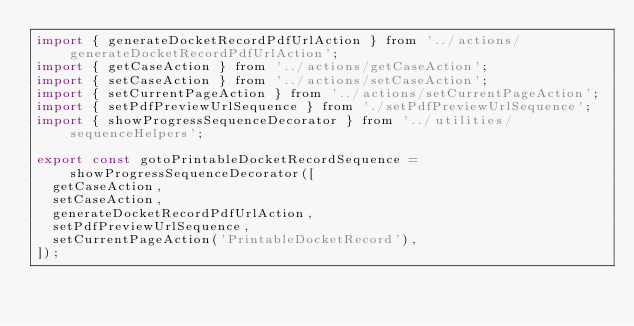Convert code to text. <code><loc_0><loc_0><loc_500><loc_500><_JavaScript_>import { generateDocketRecordPdfUrlAction } from '../actions/generateDocketRecordPdfUrlAction';
import { getCaseAction } from '../actions/getCaseAction';
import { setCaseAction } from '../actions/setCaseAction';
import { setCurrentPageAction } from '../actions/setCurrentPageAction';
import { setPdfPreviewUrlSequence } from './setPdfPreviewUrlSequence';
import { showProgressSequenceDecorator } from '../utilities/sequenceHelpers';

export const gotoPrintableDocketRecordSequence = showProgressSequenceDecorator([
  getCaseAction,
  setCaseAction,
  generateDocketRecordPdfUrlAction,
  setPdfPreviewUrlSequence,
  setCurrentPageAction('PrintableDocketRecord'),
]);
</code> 